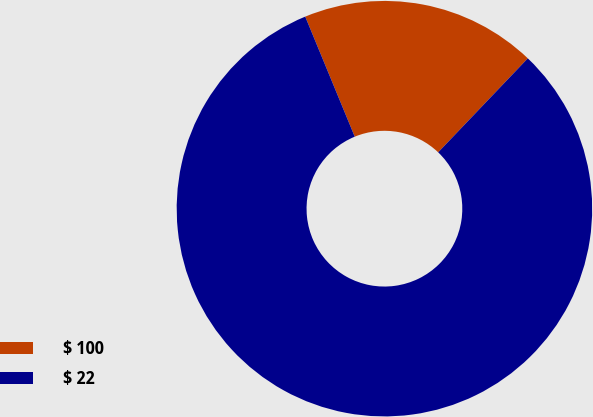Convert chart to OTSL. <chart><loc_0><loc_0><loc_500><loc_500><pie_chart><fcel>$ 100<fcel>$ 22<nl><fcel>18.35%<fcel>81.65%<nl></chart> 